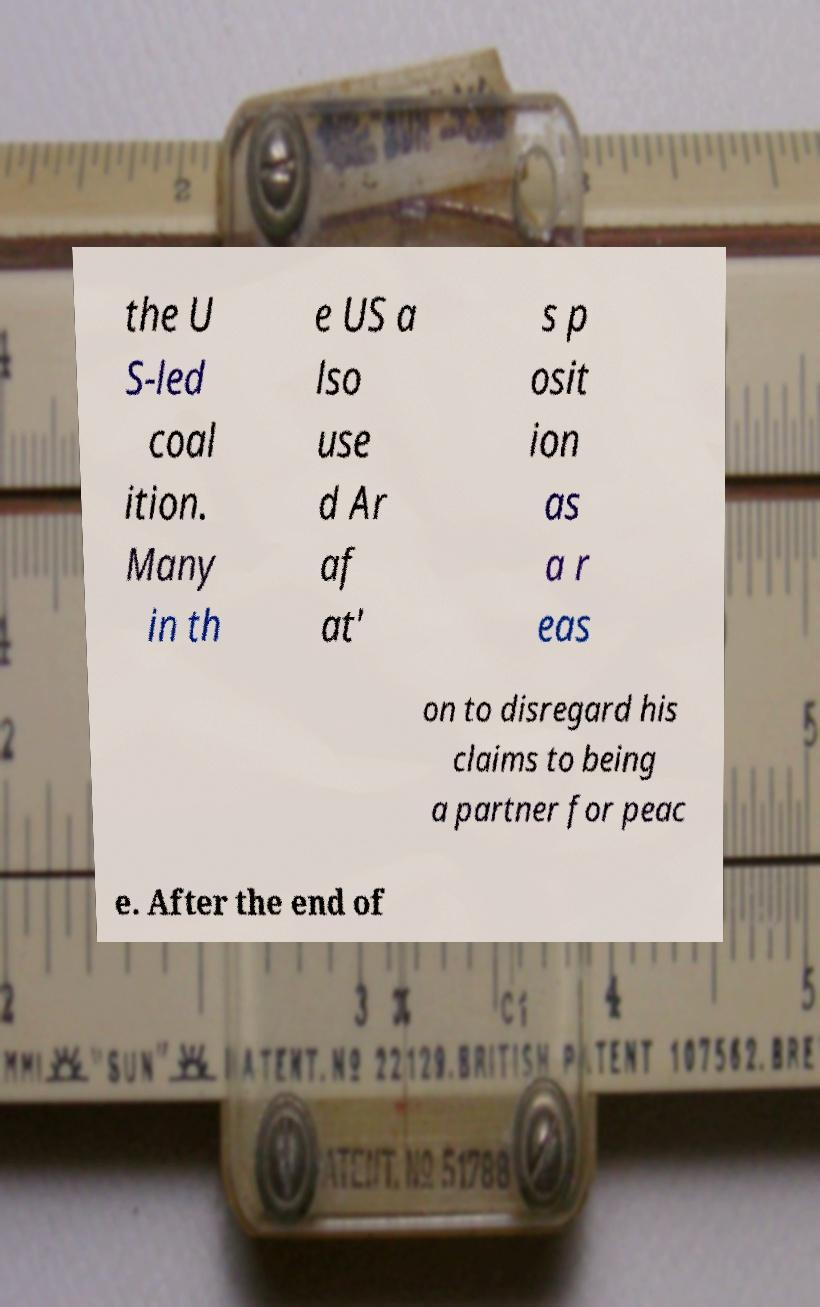For documentation purposes, I need the text within this image transcribed. Could you provide that? the U S-led coal ition. Many in th e US a lso use d Ar af at' s p osit ion as a r eas on to disregard his claims to being a partner for peac e. After the end of 